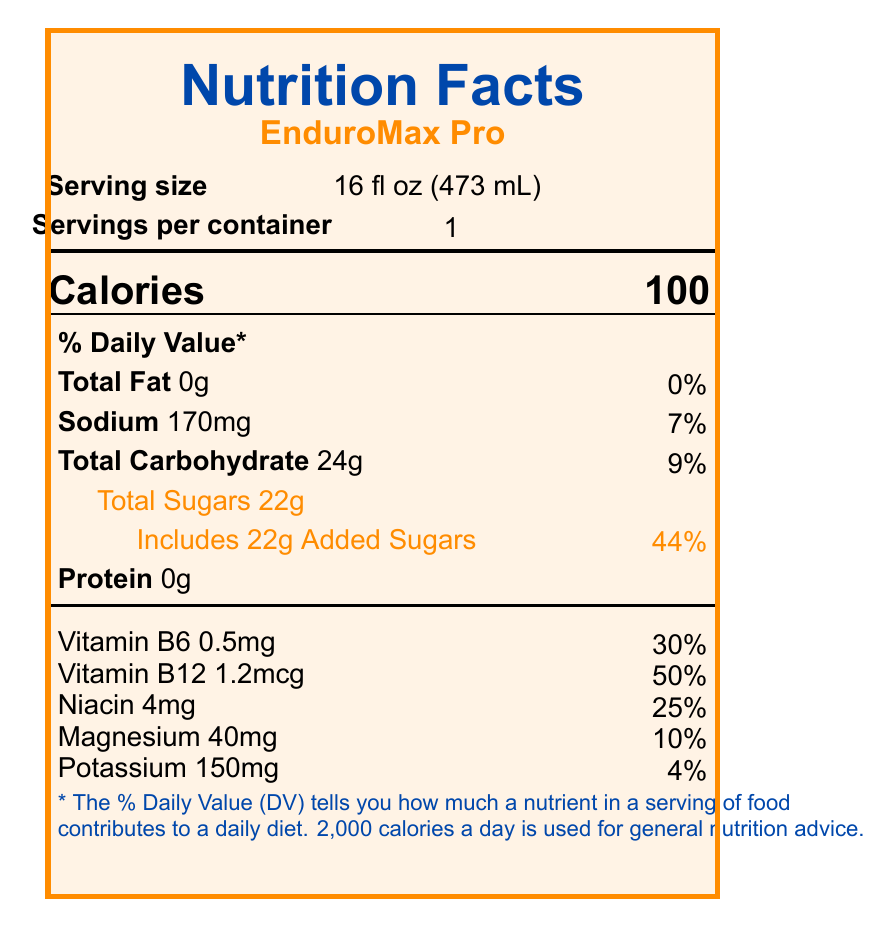what is the serving size? The serving size is mentioned under the "Serving size" section on the document.
Answer: 16 fl oz (473 mL) how many calories are in one serving of EnduroMax Pro? The calories are listed in a bold and large font under the "Calories" section.
Answer: 100 what is the total carbohydrate content per serving? The total carbohydrate content per serving is listed under the "Total Carbohydrate" section.
Answer: 24g what percentage of the daily value does the sodium content in EnduroMax Pro represent? The sodium content's daily value percentage is presented next to the sodium amount (170mg).
Answer: 7% how much protein is in one serving of EnduroMax Pro? The protein content per serving is listed as 0g under the "Protein" section.
Answer: 0g what percentage of the daily value does the added sugars in one serving represent? A. 22% B. 44% C. 9% D. 7% The percentage of the daily value for added sugars is 44%, shown next to "Includes 22g Added Sugars".
Answer: B which vitamin has the highest daily value percentage in EnduroMax Pro? A. Vitamin B6 B. Vitamin B12 C. Niacin D. Magnesium Vitamin B12 has the highest daily value percentage at 50%.
Answer: B is EnduroMax Pro produced in a facility that also processes allergens? The document states that it is produced in a facility that processes soy and milk products under "allergen_info".
Answer: Yes what is the primary usage instruction for EnduroMax Pro? This is listed under "usage_instructions".
Answer: Drink before and during intense training sessions. For best results, consume chilled. how long should the product be consumed after opening? This information is found under the "storage" section.
Answer: Consume within 3 days of opening summarize the main idea of the document. The summary includes the product’s nutritional profile, purpose, and essential handling information as presented on the document.
Answer: The document presents the nutrition facts of EnduroMax Pro, a vitamin-enriched sports drink designed to enhance endurance during long practices. It details the serving size, calories, breakdown of nutrients, vitamins and minerals, ingredients, allergen information, and usage and storage instructions. how much caffeine is in EnduroMax Pro? The document does not provide information about the caffeine content of EnduroMax Pro.
Answer: Cannot be determined 